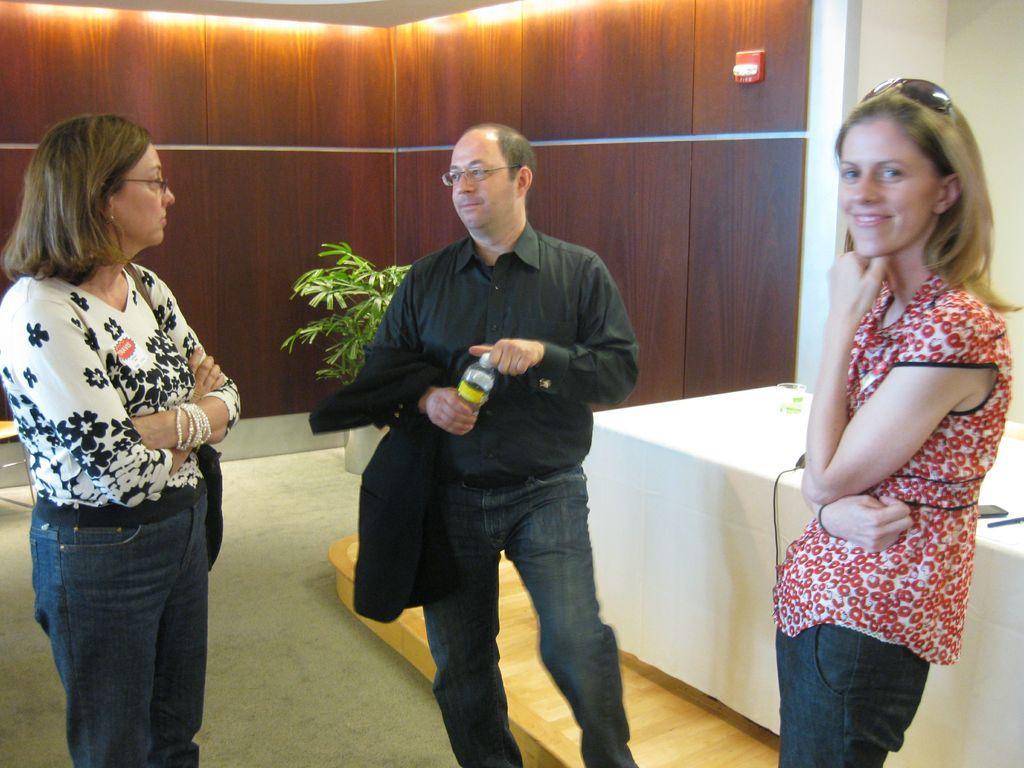Describe this image in one or two sentences. In this image we can see a man standing on the floor holding a bottle. We can also see two women standing beside him. On the backside we can see a table, a wall, plant, roof and ceiling light. 